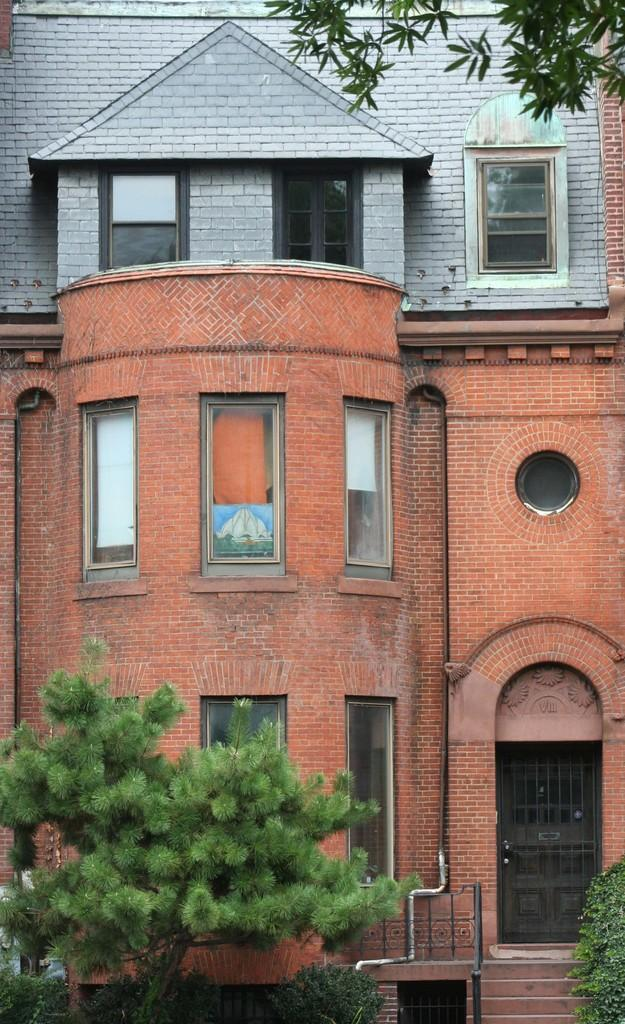What is the main structure in the image? There is a building in the center of the image. What is located at the bottom of the image? There is a door and trees at the bottom of the image. Are there any architectural features at the bottom of the image? Yes, there are stairs at the bottom of the image. What type of toothbrush is hanging on the door in the image? There is no toothbrush present in the image. What is the building used for in the image? The image does not provide information about the building's purpose or the learning that takes place inside. 